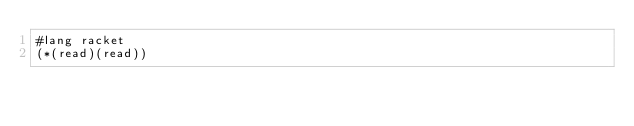<code> <loc_0><loc_0><loc_500><loc_500><_Racket_>#lang racket
(*(read)(read))</code> 